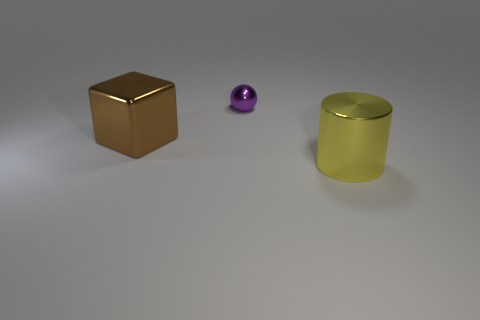How many cubes are either brown shiny objects or cyan shiny things?
Offer a very short reply. 1. Is there anything else that has the same shape as the tiny purple metal thing?
Ensure brevity in your answer.  No. Is the number of big metal cubes behind the tiny sphere greater than the number of metallic cubes that are behind the shiny block?
Offer a very short reply. No. How many purple metal objects are behind the large shiny object behind the yellow cylinder?
Your answer should be compact. 1. What number of things are tiny balls or tiny green spheres?
Provide a short and direct response. 1. What is the purple sphere made of?
Ensure brevity in your answer.  Metal. How many metal things are both behind the metallic cylinder and in front of the sphere?
Make the answer very short. 1. Is the brown metallic thing the same size as the yellow shiny cylinder?
Your response must be concise. Yes. Do the purple object that is behind the shiny cube and the big yellow thing have the same size?
Provide a succinct answer. No. What color is the metal thing that is behind the cube?
Provide a short and direct response. Purple. 